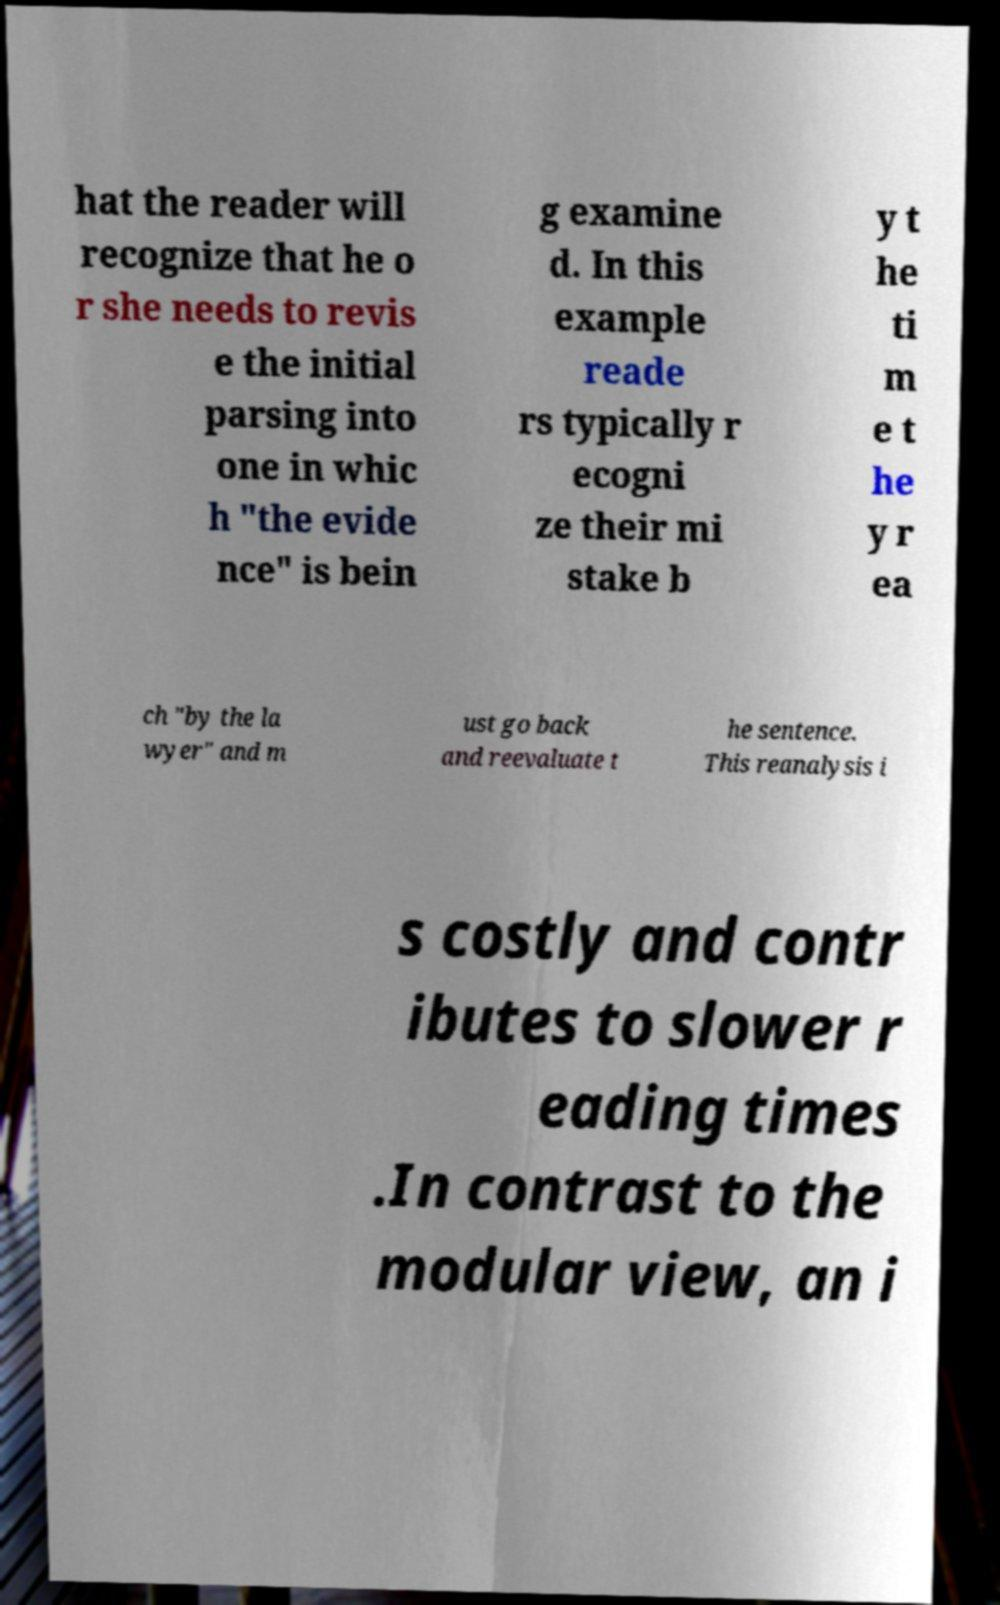Please identify and transcribe the text found in this image. hat the reader will recognize that he o r she needs to revis e the initial parsing into one in whic h "the evide nce" is bein g examine d. In this example reade rs typically r ecogni ze their mi stake b y t he ti m e t he y r ea ch "by the la wyer" and m ust go back and reevaluate t he sentence. This reanalysis i s costly and contr ibutes to slower r eading times .In contrast to the modular view, an i 